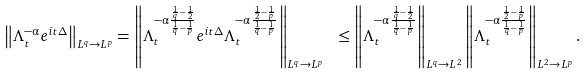Convert formula to latex. <formula><loc_0><loc_0><loc_500><loc_500>\left \| \Lambda _ { t } ^ { - \alpha } e ^ { i t \Delta } \right \| _ { L ^ { q } \rightarrow L ^ { p } } = \left \| \Lambda _ { t } ^ { - \alpha \frac { \frac { 1 } { q } - \frac { 1 } { 2 } } { \frac { 1 } { q } - \frac { 1 } { p } } } e ^ { i t \Delta } \Lambda _ { t } ^ { - \alpha \frac { \frac { 1 } { 2 } - \frac { 1 } { p } } { \frac { 1 } { q } - \frac { 1 } { p } } } \right \| _ { L ^ { q } \rightarrow L ^ { p } } \ \leq \left \| \Lambda _ { t } ^ { - \alpha \frac { \frac { 1 } { q } - \frac { 1 } { 2 } } { \frac { 1 } { q } - \frac { 1 } { p } } } \right \| _ { L ^ { q } \rightarrow L ^ { 2 } } \left \| \Lambda _ { t } ^ { - \alpha \frac { \frac { 1 } { 2 } - \frac { 1 } { p } } { \frac { 1 } { q } - \frac { 1 } { p } } } \right \| _ { L ^ { 2 } \rightarrow L ^ { p } } .</formula> 